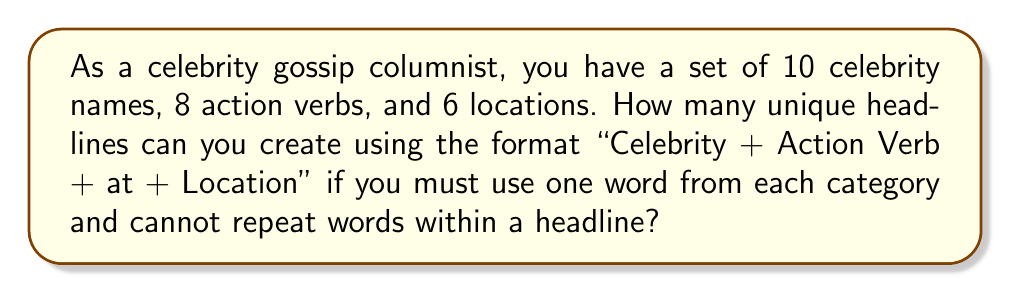Give your solution to this math problem. Let's approach this step-by-step:

1) We are creating headlines in the format: "Celebrity + Action Verb + at + Location"

2) We have:
   - 10 celebrity names
   - 8 action verbs
   - 6 locations

3) For each headline, we need to choose:
   - 1 celebrity name out of 10
   - 1 action verb out of 8
   - 1 location out of 6

4) According to the multiplication principle in combinatorics, if we have a series of independent choices, where there are $m$ ways of making the first choice, $n$ ways of making the second choice, and $p$ ways of making the third choice, then there are $m \times n \times p$ ways to make the sequence of choices.

5) In this case, we have:
   - 10 ways to choose the celebrity
   - 8 ways to choose the action verb
   - 6 ways to choose the location

6) Therefore, the total number of unique headlines is:

   $$ 10 \times 8 \times 6 = 480 $$

Thus, you can create 480 unique celebrity gossip headlines using this format and set of words.
Answer: 480 